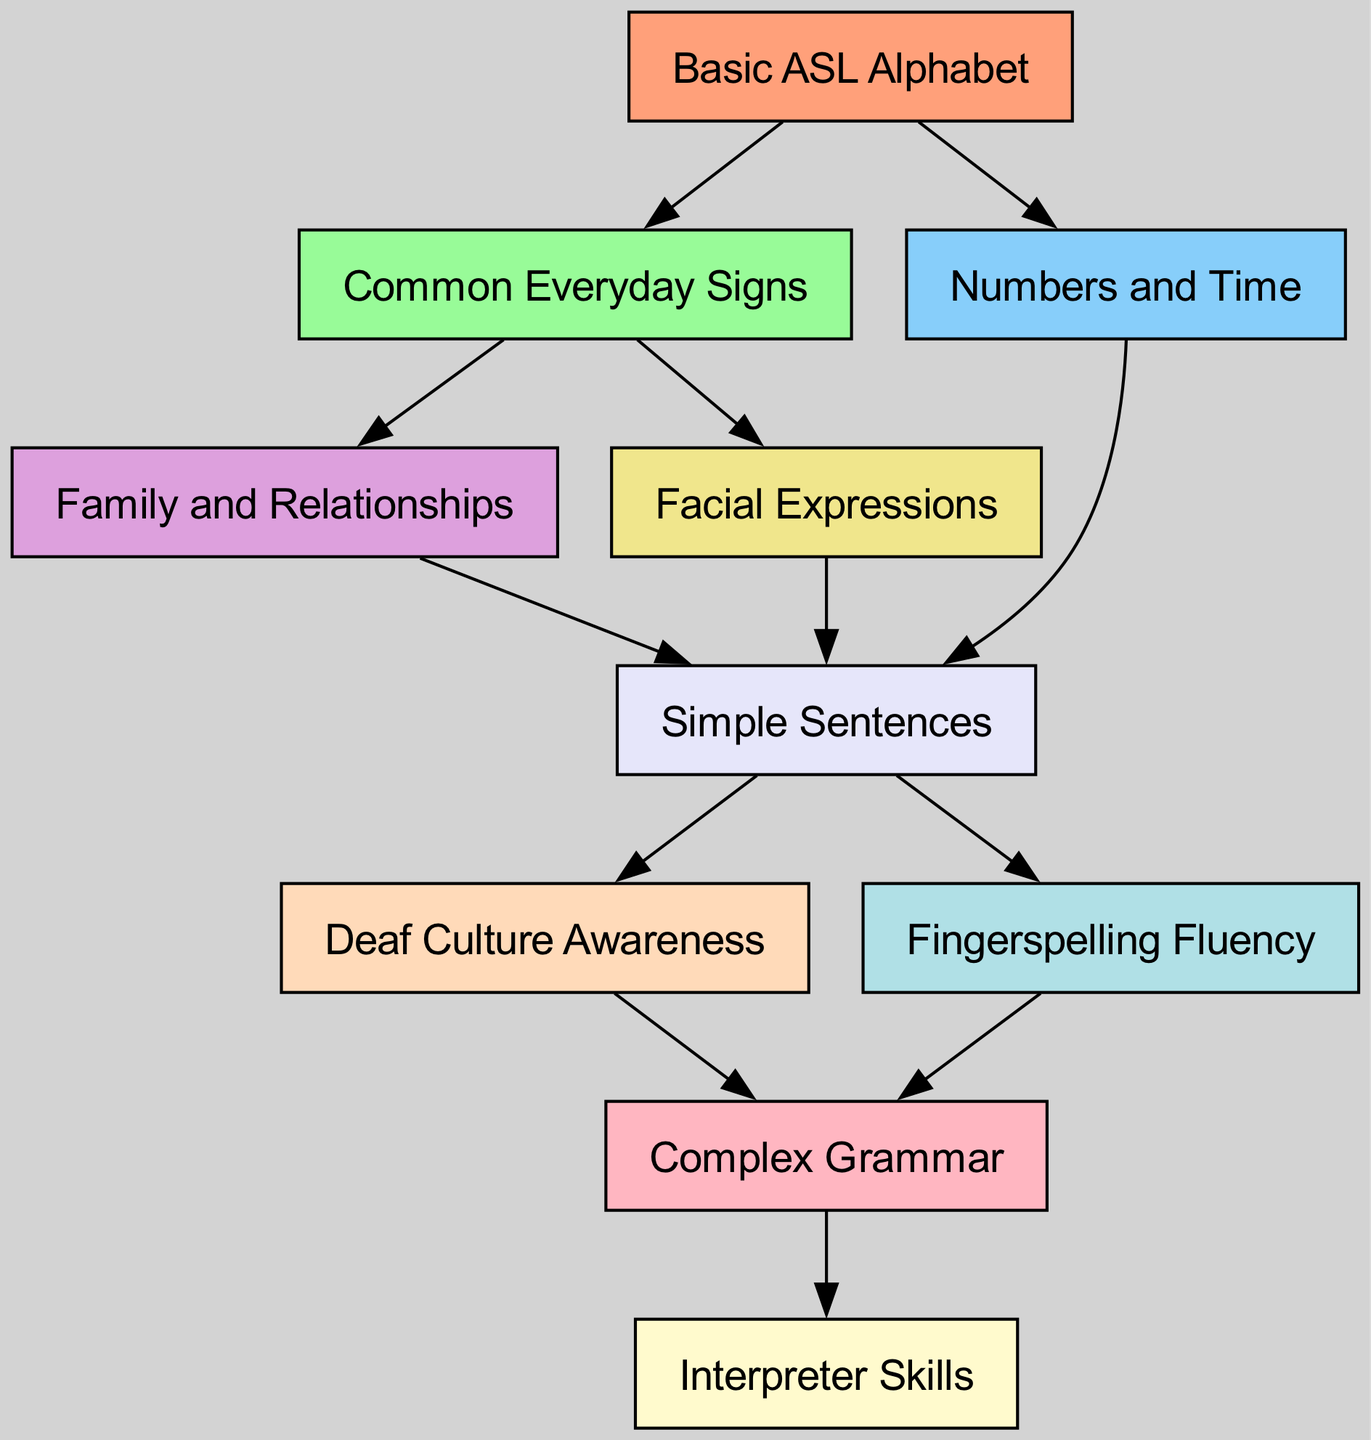What is the first step in learning sign language? The diagram shows that the first step is "Basic ASL Alphabet," which is depicted at the starting point of the graph.
Answer: Basic ASL Alphabet How many nodes are present in the diagram? By counting the distinct nodes listed, there are a total of ten nodes representing various skills and levels in learning sign language.
Answer: 10 Which skill follows "Simple Sentences" in the learning process? The directed graph shows that "Deaf Culture Awareness" and "Fingerspelling Fluency" both follow "Simple Sentences," as they are directly connected by edges from that node.
Answer: Deaf Culture Awareness, Fingerspelling Fluency What skill is achieved after "Complex Grammar"? The diagram indicates "Interpreter Skills" is the skill that follows "Complex Grammar," as there is a direct edge leading from "Complex Grammar" to "Interpreter Skills."
Answer: Interpreter Skills Which two nodes are connected by an edge coming from "Common Everyday Signs"? The nodes that are directly connected by an edge from "Common Everyday Signs" are "Family and Relationships" and "Facial Expressions," indicating they stem from that stage of learning.
Answer: Family and Relationships, Facial Expressions Which node has the most connections leading out from it? By analyzing the graph, "Simple Sentences" has the most connections, leading to three other nodes: "Deaf Culture Awareness," "Fingerspelling Fluency," and through further connections, eventually leads to "Complex Grammar."
Answer: Simple Sentences What node is a prerequisite for "Complex Grammar"? The diagram reveals that both "Deaf Culture Awareness" and "Fingerspelling Fluency" must be mastered before moving on to "Complex Grammar," as these nodes lead directly to it.
Answer: Deaf Culture Awareness, Fingerspelling Fluency How many edges are there in total? Each connection in the diagram represents an edge, and by counting them, we find that there are a total of twelve edges illustrating the relationships among the nodes.
Answer: 12 Which skill can be acquired directly after learning numbers? According to the directed graph, the skill that can be learned immediately after "Numbers and Time" is "Simple Sentences," since there is a direct edge from the former to the latter.
Answer: Simple Sentences 